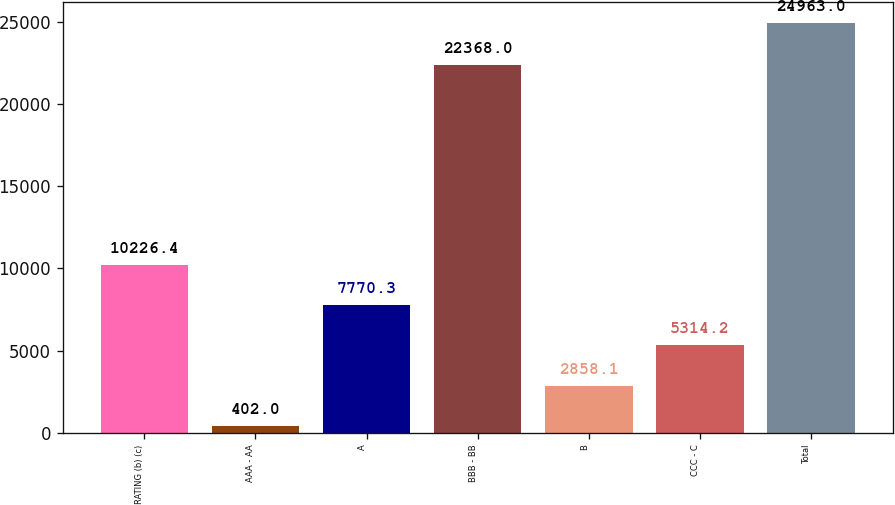Convert chart to OTSL. <chart><loc_0><loc_0><loc_500><loc_500><bar_chart><fcel>RATING (b) (c)<fcel>AAA - AA<fcel>A<fcel>BBB - BB<fcel>B<fcel>CCC - C<fcel>Total<nl><fcel>10226.4<fcel>402<fcel>7770.3<fcel>22368<fcel>2858.1<fcel>5314.2<fcel>24963<nl></chart> 